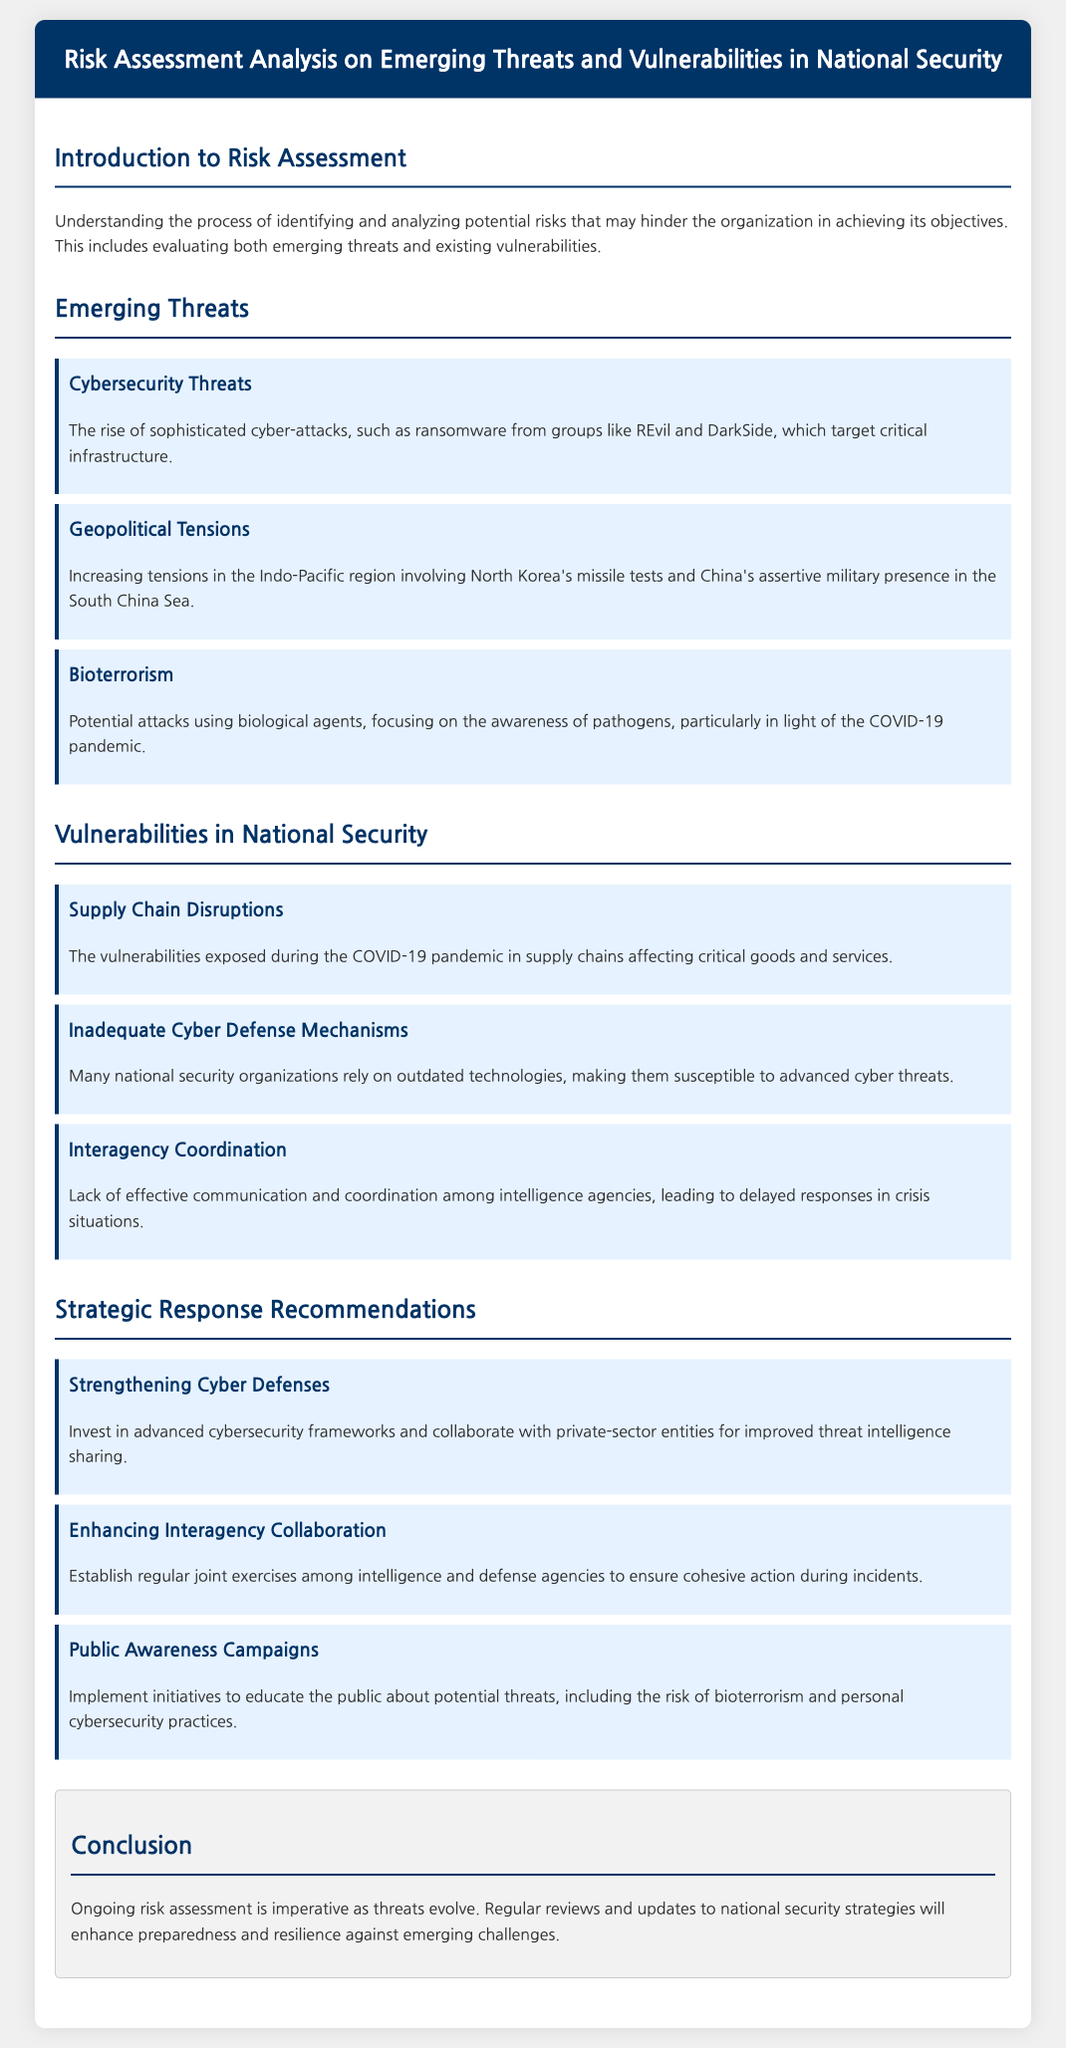What is the main focus of the document? The main focus of the document is to evaluate risks associated with emerging threats and vulnerabilities in national security and recommend strategic responses.
Answer: Emerging threats and vulnerabilities in national security What type of threats are discussed under "Emerging Threats"? "Emerging Threats" section includes various types of threats that are becoming significant, such as cybersecurity threats, geopolitical tensions, and bioterrorism.
Answer: Cybersecurity threats, geopolitical tensions, bioterrorism What is a highlighted vulnerability affecting national security? The document identifies several vulnerabilities affecting national security, including supply chain disruptions and inadequate cyber defense mechanisms.
Answer: Supply chain disruptions What recommendation is made regarding cyber defenses? The document suggests investing in advanced cybersecurity frameworks and collaborating with private-sector entities for improved threat intelligence sharing.
Answer: Strengthening Cyber Defenses How does the document propose to enhance interagency collaboration? It recommends establishing regular joint exercises among intelligence and defense agencies to ensure cohesive action during incidents.
Answer: Regular joint exercises Which significant pandemic-related issue is mentioned? The COVID-19 pandemic exposed vulnerabilities in various domains, particularly impacting supply chains for critical goods and services.
Answer: Supply Chain Disruptions What is the conclusion emphasized in the document? The conclusion emphasizes the necessity of ongoing risk assessment and regular updates to national security strategies to adapt to evolving threats.
Answer: Ongoing risk assessment 